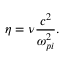Convert formula to latex. <formula><loc_0><loc_0><loc_500><loc_500>\eta = \nu { \frac { c ^ { 2 } } { \omega _ { p i } ^ { 2 } } } .</formula> 